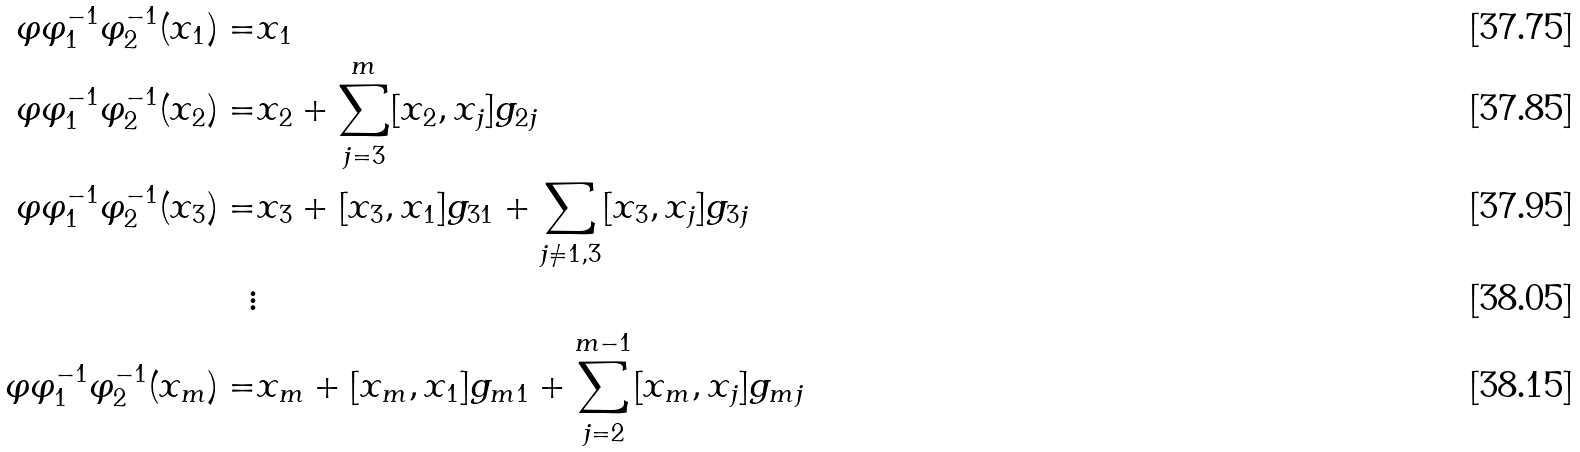Convert formula to latex. <formula><loc_0><loc_0><loc_500><loc_500>\varphi \varphi _ { 1 } ^ { - 1 } \varphi _ { 2 } ^ { - 1 } ( x _ { 1 } ) = & x _ { 1 } \\ \varphi \varphi _ { 1 } ^ { - 1 } \varphi _ { 2 } ^ { - 1 } ( x _ { 2 } ) = & x _ { 2 } + \sum _ { j = 3 } ^ { m } [ x _ { 2 } , x _ { j } ] g _ { 2 j } \\ \varphi \varphi _ { 1 } ^ { - 1 } \varphi _ { 2 } ^ { - 1 } ( x _ { 3 } ) = & x _ { 3 } + [ x _ { 3 } , x _ { 1 } ] g _ { 3 1 } + \sum _ { j \neq 1 , 3 } [ x _ { 3 } , x _ { j } ] g _ { 3 j } \\ \vdots & \\ \varphi \varphi _ { 1 } ^ { - 1 } \varphi _ { 2 } ^ { - 1 } ( x _ { m } ) = & x _ { m } + [ x _ { m } , x _ { 1 } ] g _ { m 1 } + \sum _ { j = 2 } ^ { m - 1 } [ x _ { m } , x _ { j } ] g _ { m j }</formula> 